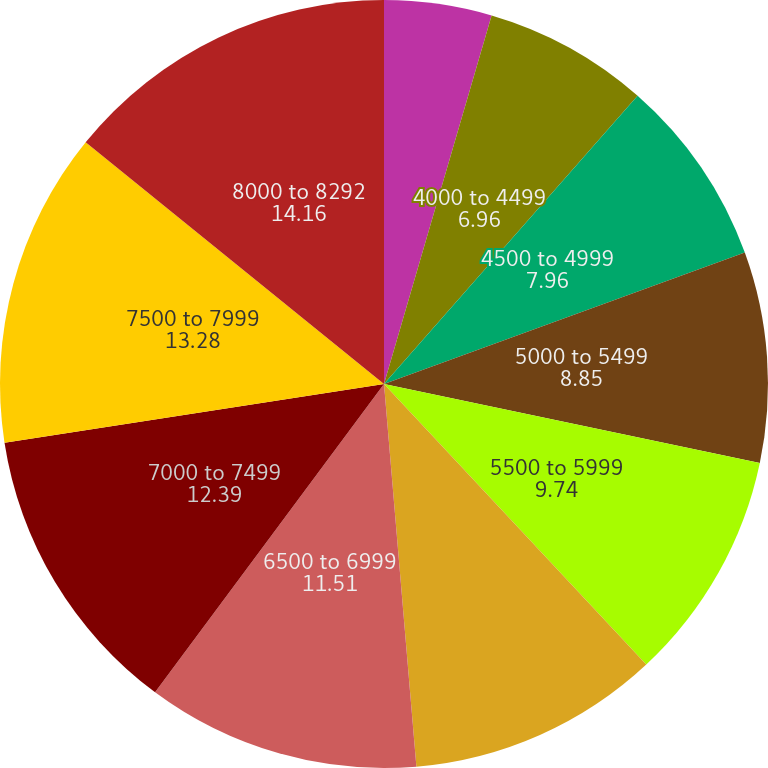Convert chart to OTSL. <chart><loc_0><loc_0><loc_500><loc_500><pie_chart><fcel>2000 to 3999<fcel>4000 to 4499<fcel>4500 to 4999<fcel>5000 to 5499<fcel>5500 to 5999<fcel>6000 to 6499<fcel>6500 to 6999<fcel>7000 to 7499<fcel>7500 to 7999<fcel>8000 to 8292<nl><fcel>4.52%<fcel>6.96%<fcel>7.96%<fcel>8.85%<fcel>9.74%<fcel>10.62%<fcel>11.51%<fcel>12.39%<fcel>13.28%<fcel>14.16%<nl></chart> 